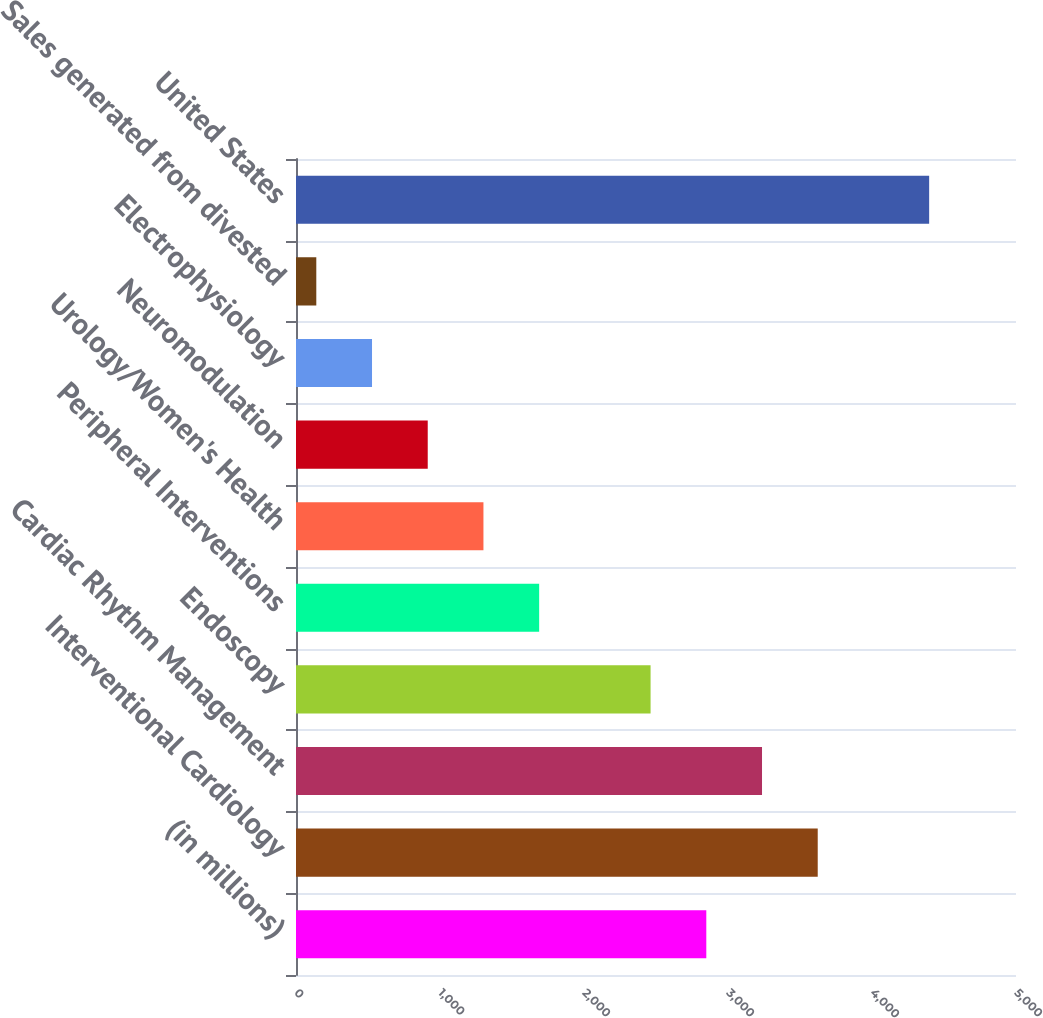Convert chart. <chart><loc_0><loc_0><loc_500><loc_500><bar_chart><fcel>(in millions)<fcel>Interventional Cardiology<fcel>Cardiac Rhythm Management<fcel>Endoscopy<fcel>Peripheral Interventions<fcel>Urology/Women's Health<fcel>Neuromodulation<fcel>Electrophysiology<fcel>Sales generated from divested<fcel>United States<nl><fcel>2849.3<fcel>3623.1<fcel>3236.2<fcel>2462.4<fcel>1688.6<fcel>1301.7<fcel>914.8<fcel>527.9<fcel>141<fcel>4396.9<nl></chart> 